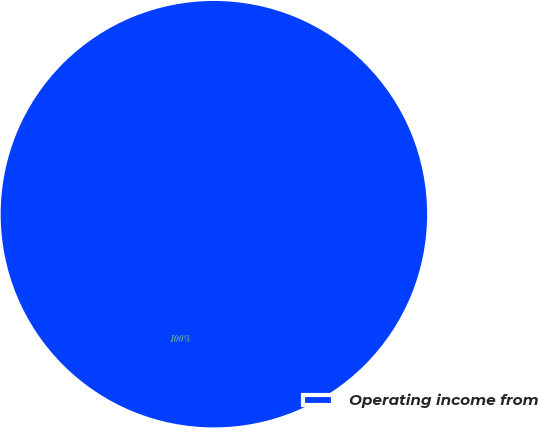Convert chart. <chart><loc_0><loc_0><loc_500><loc_500><pie_chart><fcel>Operating income from<nl><fcel>100.0%<nl></chart> 